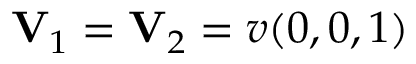<formula> <loc_0><loc_0><loc_500><loc_500>V _ { 1 } = V _ { 2 } = v ( 0 , 0 , 1 )</formula> 